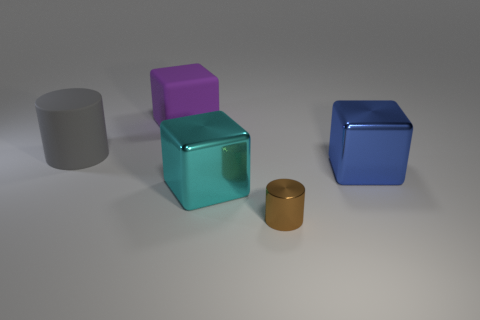The gray matte object has what size?
Your response must be concise. Large. What size is the metallic thing that is in front of the big metal thing that is left of the cylinder on the right side of the large gray cylinder?
Provide a short and direct response. Small. Is there a small brown object that has the same material as the brown cylinder?
Your answer should be very brief. No. The purple rubber thing has what shape?
Ensure brevity in your answer.  Cube. The block that is the same material as the big gray thing is what color?
Give a very brief answer. Purple. How many gray things are either cylinders or big metallic cubes?
Give a very brief answer. 1. Are there more big cyan metallic objects than green rubber cylinders?
Ensure brevity in your answer.  Yes. What number of things are either large purple matte cubes behind the brown object or big things in front of the big matte block?
Provide a succinct answer. 4. The metallic cube that is the same size as the cyan thing is what color?
Give a very brief answer. Blue. Does the large gray cylinder have the same material as the purple object?
Your answer should be compact. Yes. 